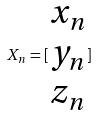Convert formula to latex. <formula><loc_0><loc_0><loc_500><loc_500>X _ { n } = [ \begin{matrix} x _ { n } \\ y _ { n } \\ z _ { n } \end{matrix} ]</formula> 